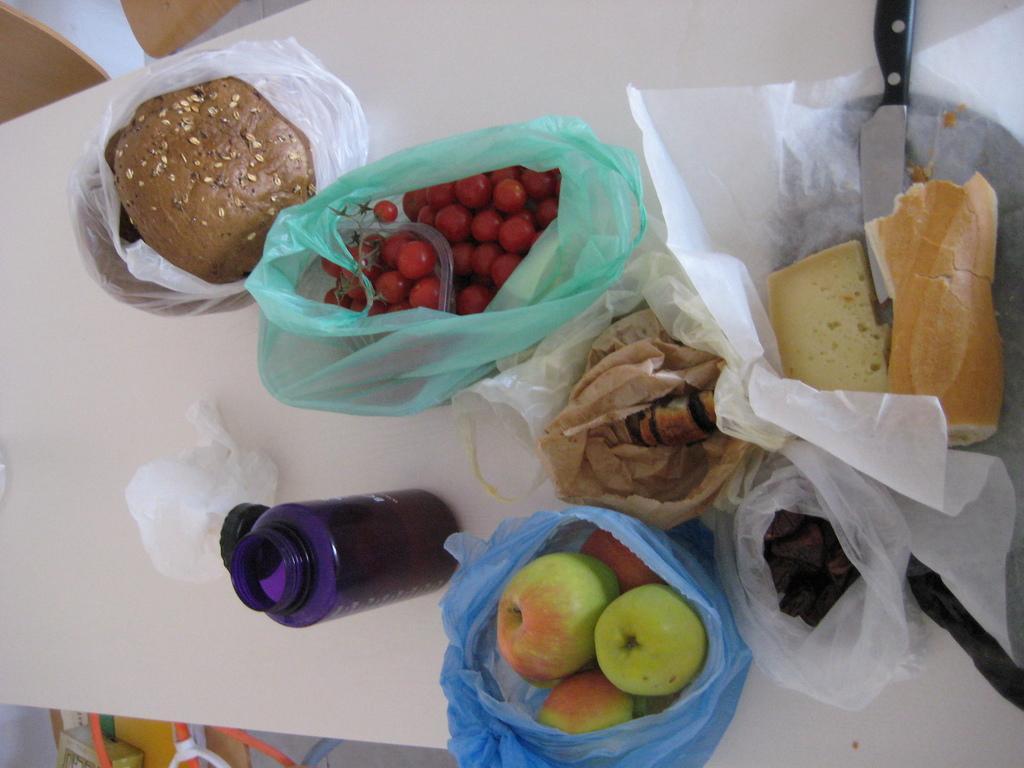Please provide a concise description of this image. In this image I can see a table on which there are so many food items in the covers, beside them there is a knife and bottle. 